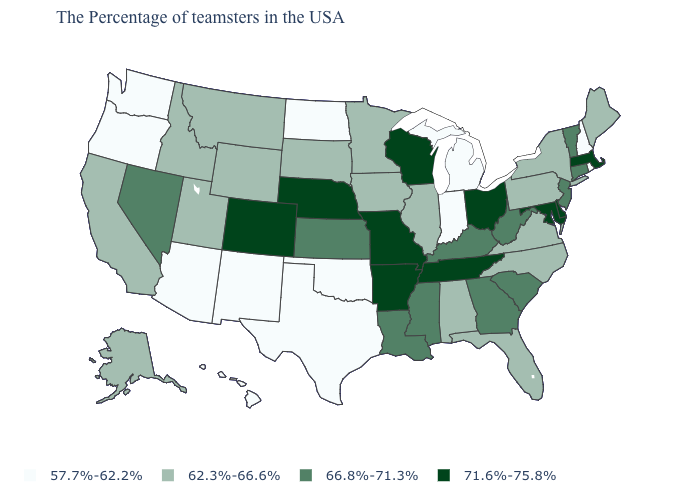Which states have the lowest value in the USA?
Concise answer only. Rhode Island, New Hampshire, Michigan, Indiana, Oklahoma, Texas, North Dakota, New Mexico, Arizona, Washington, Oregon, Hawaii. Name the states that have a value in the range 62.3%-66.6%?
Keep it brief. Maine, New York, Pennsylvania, Virginia, North Carolina, Florida, Alabama, Illinois, Minnesota, Iowa, South Dakota, Wyoming, Utah, Montana, Idaho, California, Alaska. What is the value of South Dakota?
Write a very short answer. 62.3%-66.6%. What is the value of South Dakota?
Give a very brief answer. 62.3%-66.6%. Among the states that border Minnesota , which have the lowest value?
Quick response, please. North Dakota. What is the value of Florida?
Quick response, please. 62.3%-66.6%. How many symbols are there in the legend?
Be succinct. 4. What is the highest value in the USA?
Give a very brief answer. 71.6%-75.8%. Does New York have the lowest value in the USA?
Concise answer only. No. What is the value of Vermont?
Concise answer only. 66.8%-71.3%. Is the legend a continuous bar?
Give a very brief answer. No. Name the states that have a value in the range 71.6%-75.8%?
Give a very brief answer. Massachusetts, Delaware, Maryland, Ohio, Tennessee, Wisconsin, Missouri, Arkansas, Nebraska, Colorado. Does Connecticut have a lower value than Texas?
Short answer required. No. Name the states that have a value in the range 66.8%-71.3%?
Write a very short answer. Vermont, Connecticut, New Jersey, South Carolina, West Virginia, Georgia, Kentucky, Mississippi, Louisiana, Kansas, Nevada. 